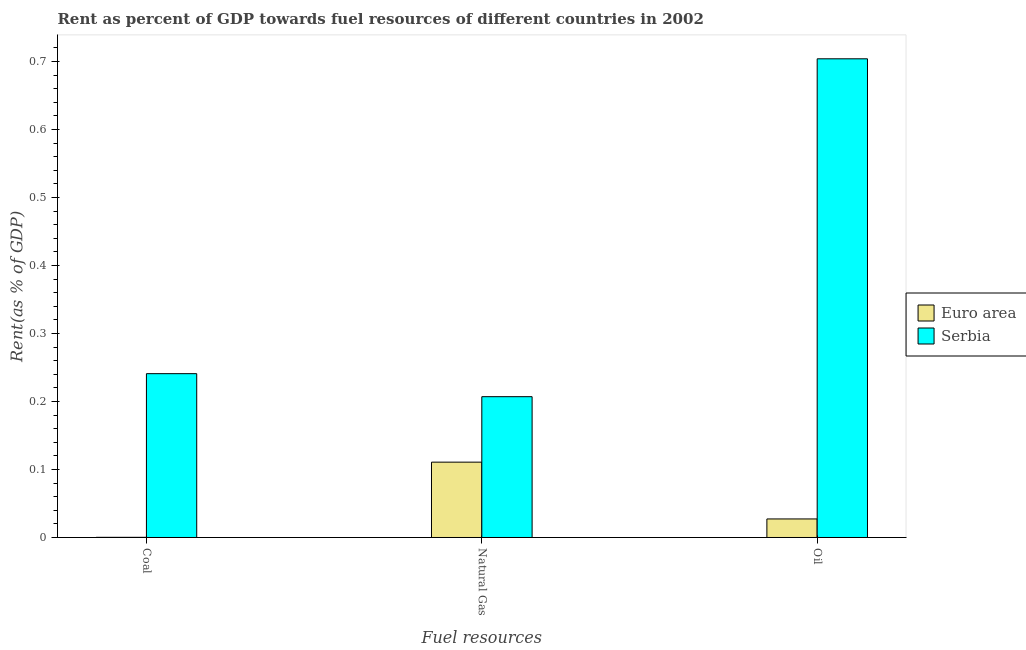How many groups of bars are there?
Keep it short and to the point. 3. Are the number of bars per tick equal to the number of legend labels?
Your response must be concise. Yes. How many bars are there on the 2nd tick from the left?
Offer a terse response. 2. How many bars are there on the 1st tick from the right?
Your answer should be compact. 2. What is the label of the 2nd group of bars from the left?
Offer a very short reply. Natural Gas. What is the rent towards natural gas in Serbia?
Keep it short and to the point. 0.21. Across all countries, what is the maximum rent towards natural gas?
Your response must be concise. 0.21. Across all countries, what is the minimum rent towards oil?
Ensure brevity in your answer.  0.03. In which country was the rent towards natural gas maximum?
Keep it short and to the point. Serbia. What is the total rent towards coal in the graph?
Keep it short and to the point. 0.24. What is the difference between the rent towards coal in Serbia and that in Euro area?
Provide a short and direct response. 0.24. What is the difference between the rent towards oil in Serbia and the rent towards coal in Euro area?
Offer a terse response. 0.7. What is the average rent towards natural gas per country?
Make the answer very short. 0.16. What is the difference between the rent towards oil and rent towards natural gas in Euro area?
Keep it short and to the point. -0.08. What is the ratio of the rent towards coal in Serbia to that in Euro area?
Provide a short and direct response. 976.03. Is the difference between the rent towards oil in Serbia and Euro area greater than the difference between the rent towards coal in Serbia and Euro area?
Make the answer very short. Yes. What is the difference between the highest and the second highest rent towards coal?
Make the answer very short. 0.24. What is the difference between the highest and the lowest rent towards coal?
Ensure brevity in your answer.  0.24. In how many countries, is the rent towards coal greater than the average rent towards coal taken over all countries?
Provide a succinct answer. 1. What does the 1st bar from the left in Coal represents?
Your answer should be compact. Euro area. What does the 1st bar from the right in Coal represents?
Your answer should be very brief. Serbia. How many bars are there?
Offer a terse response. 6. Does the graph contain any zero values?
Give a very brief answer. No. Does the graph contain grids?
Ensure brevity in your answer.  No. How many legend labels are there?
Your answer should be very brief. 2. What is the title of the graph?
Provide a short and direct response. Rent as percent of GDP towards fuel resources of different countries in 2002. Does "Lower middle income" appear as one of the legend labels in the graph?
Give a very brief answer. No. What is the label or title of the X-axis?
Ensure brevity in your answer.  Fuel resources. What is the label or title of the Y-axis?
Provide a succinct answer. Rent(as % of GDP). What is the Rent(as % of GDP) in Euro area in Coal?
Ensure brevity in your answer.  0. What is the Rent(as % of GDP) of Serbia in Coal?
Provide a short and direct response. 0.24. What is the Rent(as % of GDP) of Euro area in Natural Gas?
Provide a short and direct response. 0.11. What is the Rent(as % of GDP) of Serbia in Natural Gas?
Give a very brief answer. 0.21. What is the Rent(as % of GDP) of Euro area in Oil?
Offer a very short reply. 0.03. What is the Rent(as % of GDP) of Serbia in Oil?
Your answer should be very brief. 0.7. Across all Fuel resources, what is the maximum Rent(as % of GDP) in Euro area?
Your response must be concise. 0.11. Across all Fuel resources, what is the maximum Rent(as % of GDP) of Serbia?
Keep it short and to the point. 0.7. Across all Fuel resources, what is the minimum Rent(as % of GDP) of Euro area?
Provide a short and direct response. 0. Across all Fuel resources, what is the minimum Rent(as % of GDP) of Serbia?
Provide a succinct answer. 0.21. What is the total Rent(as % of GDP) in Euro area in the graph?
Make the answer very short. 0.14. What is the total Rent(as % of GDP) in Serbia in the graph?
Your response must be concise. 1.15. What is the difference between the Rent(as % of GDP) in Euro area in Coal and that in Natural Gas?
Provide a succinct answer. -0.11. What is the difference between the Rent(as % of GDP) of Serbia in Coal and that in Natural Gas?
Provide a succinct answer. 0.03. What is the difference between the Rent(as % of GDP) of Euro area in Coal and that in Oil?
Offer a terse response. -0.03. What is the difference between the Rent(as % of GDP) of Serbia in Coal and that in Oil?
Make the answer very short. -0.46. What is the difference between the Rent(as % of GDP) of Euro area in Natural Gas and that in Oil?
Ensure brevity in your answer.  0.08. What is the difference between the Rent(as % of GDP) in Serbia in Natural Gas and that in Oil?
Provide a short and direct response. -0.5. What is the difference between the Rent(as % of GDP) in Euro area in Coal and the Rent(as % of GDP) in Serbia in Natural Gas?
Offer a very short reply. -0.21. What is the difference between the Rent(as % of GDP) of Euro area in Coal and the Rent(as % of GDP) of Serbia in Oil?
Your answer should be compact. -0.7. What is the difference between the Rent(as % of GDP) in Euro area in Natural Gas and the Rent(as % of GDP) in Serbia in Oil?
Provide a short and direct response. -0.59. What is the average Rent(as % of GDP) in Euro area per Fuel resources?
Your answer should be compact. 0.05. What is the average Rent(as % of GDP) in Serbia per Fuel resources?
Offer a very short reply. 0.38. What is the difference between the Rent(as % of GDP) of Euro area and Rent(as % of GDP) of Serbia in Coal?
Ensure brevity in your answer.  -0.24. What is the difference between the Rent(as % of GDP) in Euro area and Rent(as % of GDP) in Serbia in Natural Gas?
Offer a very short reply. -0.1. What is the difference between the Rent(as % of GDP) in Euro area and Rent(as % of GDP) in Serbia in Oil?
Your response must be concise. -0.68. What is the ratio of the Rent(as % of GDP) in Euro area in Coal to that in Natural Gas?
Your answer should be compact. 0. What is the ratio of the Rent(as % of GDP) in Serbia in Coal to that in Natural Gas?
Your response must be concise. 1.16. What is the ratio of the Rent(as % of GDP) in Euro area in Coal to that in Oil?
Offer a very short reply. 0.01. What is the ratio of the Rent(as % of GDP) of Serbia in Coal to that in Oil?
Make the answer very short. 0.34. What is the ratio of the Rent(as % of GDP) of Euro area in Natural Gas to that in Oil?
Your answer should be very brief. 4.06. What is the ratio of the Rent(as % of GDP) of Serbia in Natural Gas to that in Oil?
Provide a short and direct response. 0.29. What is the difference between the highest and the second highest Rent(as % of GDP) in Euro area?
Your response must be concise. 0.08. What is the difference between the highest and the second highest Rent(as % of GDP) of Serbia?
Provide a short and direct response. 0.46. What is the difference between the highest and the lowest Rent(as % of GDP) in Euro area?
Keep it short and to the point. 0.11. What is the difference between the highest and the lowest Rent(as % of GDP) in Serbia?
Your answer should be very brief. 0.5. 